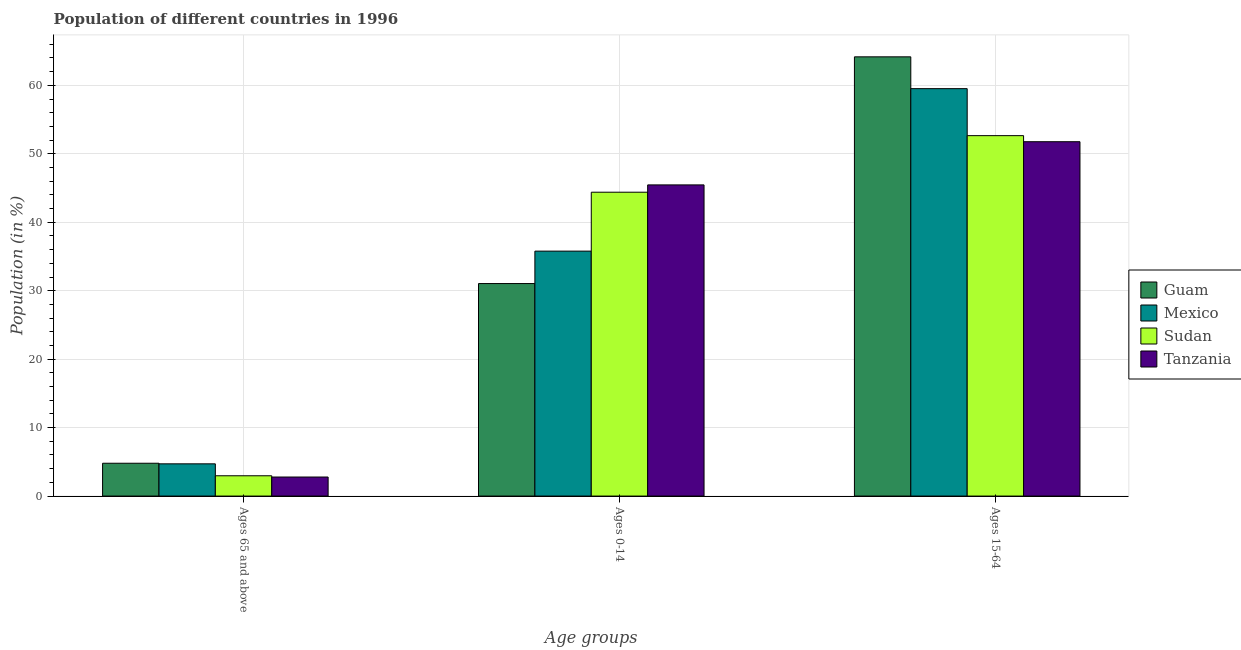How many different coloured bars are there?
Your response must be concise. 4. How many bars are there on the 2nd tick from the right?
Offer a terse response. 4. What is the label of the 2nd group of bars from the left?
Your response must be concise. Ages 0-14. What is the percentage of population within the age-group of 65 and above in Mexico?
Give a very brief answer. 4.71. Across all countries, what is the maximum percentage of population within the age-group 15-64?
Provide a short and direct response. 64.16. Across all countries, what is the minimum percentage of population within the age-group 0-14?
Give a very brief answer. 31.04. In which country was the percentage of population within the age-group of 65 and above maximum?
Your response must be concise. Guam. In which country was the percentage of population within the age-group 15-64 minimum?
Offer a terse response. Tanzania. What is the total percentage of population within the age-group of 65 and above in the graph?
Offer a terse response. 15.25. What is the difference between the percentage of population within the age-group 15-64 in Tanzania and that in Guam?
Give a very brief answer. -12.4. What is the difference between the percentage of population within the age-group 15-64 in Mexico and the percentage of population within the age-group of 65 and above in Guam?
Give a very brief answer. 54.72. What is the average percentage of population within the age-group of 65 and above per country?
Ensure brevity in your answer.  3.81. What is the difference between the percentage of population within the age-group 0-14 and percentage of population within the age-group of 65 and above in Guam?
Keep it short and to the point. 26.25. In how many countries, is the percentage of population within the age-group of 65 and above greater than 26 %?
Offer a terse response. 0. What is the ratio of the percentage of population within the age-group 0-14 in Mexico to that in Sudan?
Ensure brevity in your answer.  0.81. Is the difference between the percentage of population within the age-group 0-14 in Tanzania and Mexico greater than the difference between the percentage of population within the age-group of 65 and above in Tanzania and Mexico?
Your response must be concise. Yes. What is the difference between the highest and the second highest percentage of population within the age-group of 65 and above?
Make the answer very short. 0.09. What is the difference between the highest and the lowest percentage of population within the age-group 0-14?
Give a very brief answer. 14.41. In how many countries, is the percentage of population within the age-group 0-14 greater than the average percentage of population within the age-group 0-14 taken over all countries?
Provide a succinct answer. 2. Is the sum of the percentage of population within the age-group of 65 and above in Guam and Mexico greater than the maximum percentage of population within the age-group 15-64 across all countries?
Ensure brevity in your answer.  No. What does the 1st bar from the left in Ages 15-64 represents?
Your answer should be compact. Guam. What does the 1st bar from the right in Ages 65 and above represents?
Offer a terse response. Tanzania. Is it the case that in every country, the sum of the percentage of population within the age-group of 65 and above and percentage of population within the age-group 0-14 is greater than the percentage of population within the age-group 15-64?
Your response must be concise. No. Are all the bars in the graph horizontal?
Make the answer very short. No. Are the values on the major ticks of Y-axis written in scientific E-notation?
Offer a terse response. No. Does the graph contain any zero values?
Provide a succinct answer. No. What is the title of the graph?
Provide a short and direct response. Population of different countries in 1996. Does "Luxembourg" appear as one of the legend labels in the graph?
Make the answer very short. No. What is the label or title of the X-axis?
Ensure brevity in your answer.  Age groups. What is the label or title of the Y-axis?
Offer a terse response. Population (in %). What is the Population (in %) in Guam in Ages 65 and above?
Ensure brevity in your answer.  4.8. What is the Population (in %) of Mexico in Ages 65 and above?
Offer a terse response. 4.71. What is the Population (in %) of Sudan in Ages 65 and above?
Your answer should be very brief. 2.96. What is the Population (in %) in Tanzania in Ages 65 and above?
Provide a succinct answer. 2.78. What is the Population (in %) of Guam in Ages 0-14?
Ensure brevity in your answer.  31.04. What is the Population (in %) of Mexico in Ages 0-14?
Provide a short and direct response. 35.78. What is the Population (in %) in Sudan in Ages 0-14?
Provide a short and direct response. 44.39. What is the Population (in %) of Tanzania in Ages 0-14?
Provide a short and direct response. 45.45. What is the Population (in %) of Guam in Ages 15-64?
Give a very brief answer. 64.16. What is the Population (in %) in Mexico in Ages 15-64?
Your answer should be very brief. 59.51. What is the Population (in %) in Sudan in Ages 15-64?
Ensure brevity in your answer.  52.65. What is the Population (in %) in Tanzania in Ages 15-64?
Offer a terse response. 51.76. Across all Age groups, what is the maximum Population (in %) in Guam?
Offer a terse response. 64.16. Across all Age groups, what is the maximum Population (in %) in Mexico?
Offer a terse response. 59.51. Across all Age groups, what is the maximum Population (in %) of Sudan?
Make the answer very short. 52.65. Across all Age groups, what is the maximum Population (in %) of Tanzania?
Make the answer very short. 51.76. Across all Age groups, what is the minimum Population (in %) in Guam?
Your answer should be compact. 4.8. Across all Age groups, what is the minimum Population (in %) of Mexico?
Your answer should be compact. 4.71. Across all Age groups, what is the minimum Population (in %) in Sudan?
Provide a succinct answer. 2.96. Across all Age groups, what is the minimum Population (in %) in Tanzania?
Ensure brevity in your answer.  2.78. What is the total Population (in %) of Guam in the graph?
Offer a very short reply. 100. What is the total Population (in %) of Sudan in the graph?
Keep it short and to the point. 100. What is the difference between the Population (in %) of Guam in Ages 65 and above and that in Ages 0-14?
Offer a very short reply. -26.25. What is the difference between the Population (in %) of Mexico in Ages 65 and above and that in Ages 0-14?
Offer a very short reply. -31.07. What is the difference between the Population (in %) of Sudan in Ages 65 and above and that in Ages 0-14?
Keep it short and to the point. -41.42. What is the difference between the Population (in %) in Tanzania in Ages 65 and above and that in Ages 0-14?
Provide a succinct answer. -42.67. What is the difference between the Population (in %) of Guam in Ages 65 and above and that in Ages 15-64?
Provide a short and direct response. -59.37. What is the difference between the Population (in %) of Mexico in Ages 65 and above and that in Ages 15-64?
Give a very brief answer. -54.81. What is the difference between the Population (in %) in Sudan in Ages 65 and above and that in Ages 15-64?
Provide a succinct answer. -49.68. What is the difference between the Population (in %) of Tanzania in Ages 65 and above and that in Ages 15-64?
Offer a terse response. -48.98. What is the difference between the Population (in %) in Guam in Ages 0-14 and that in Ages 15-64?
Your response must be concise. -33.12. What is the difference between the Population (in %) of Mexico in Ages 0-14 and that in Ages 15-64?
Your answer should be compact. -23.74. What is the difference between the Population (in %) in Sudan in Ages 0-14 and that in Ages 15-64?
Your response must be concise. -8.26. What is the difference between the Population (in %) of Tanzania in Ages 0-14 and that in Ages 15-64?
Provide a short and direct response. -6.31. What is the difference between the Population (in %) of Guam in Ages 65 and above and the Population (in %) of Mexico in Ages 0-14?
Ensure brevity in your answer.  -30.98. What is the difference between the Population (in %) in Guam in Ages 65 and above and the Population (in %) in Sudan in Ages 0-14?
Your response must be concise. -39.59. What is the difference between the Population (in %) of Guam in Ages 65 and above and the Population (in %) of Tanzania in Ages 0-14?
Make the answer very short. -40.66. What is the difference between the Population (in %) in Mexico in Ages 65 and above and the Population (in %) in Sudan in Ages 0-14?
Ensure brevity in your answer.  -39.68. What is the difference between the Population (in %) of Mexico in Ages 65 and above and the Population (in %) of Tanzania in Ages 0-14?
Provide a succinct answer. -40.75. What is the difference between the Population (in %) of Sudan in Ages 65 and above and the Population (in %) of Tanzania in Ages 0-14?
Provide a short and direct response. -42.49. What is the difference between the Population (in %) in Guam in Ages 65 and above and the Population (in %) in Mexico in Ages 15-64?
Give a very brief answer. -54.72. What is the difference between the Population (in %) in Guam in Ages 65 and above and the Population (in %) in Sudan in Ages 15-64?
Your response must be concise. -47.85. What is the difference between the Population (in %) in Guam in Ages 65 and above and the Population (in %) in Tanzania in Ages 15-64?
Provide a succinct answer. -46.97. What is the difference between the Population (in %) of Mexico in Ages 65 and above and the Population (in %) of Sudan in Ages 15-64?
Your answer should be compact. -47.94. What is the difference between the Population (in %) in Mexico in Ages 65 and above and the Population (in %) in Tanzania in Ages 15-64?
Give a very brief answer. -47.06. What is the difference between the Population (in %) of Sudan in Ages 65 and above and the Population (in %) of Tanzania in Ages 15-64?
Ensure brevity in your answer.  -48.8. What is the difference between the Population (in %) of Guam in Ages 0-14 and the Population (in %) of Mexico in Ages 15-64?
Ensure brevity in your answer.  -28.47. What is the difference between the Population (in %) in Guam in Ages 0-14 and the Population (in %) in Sudan in Ages 15-64?
Your answer should be very brief. -21.61. What is the difference between the Population (in %) of Guam in Ages 0-14 and the Population (in %) of Tanzania in Ages 15-64?
Provide a succinct answer. -20.72. What is the difference between the Population (in %) of Mexico in Ages 0-14 and the Population (in %) of Sudan in Ages 15-64?
Ensure brevity in your answer.  -16.87. What is the difference between the Population (in %) of Mexico in Ages 0-14 and the Population (in %) of Tanzania in Ages 15-64?
Give a very brief answer. -15.99. What is the difference between the Population (in %) in Sudan in Ages 0-14 and the Population (in %) in Tanzania in Ages 15-64?
Offer a terse response. -7.38. What is the average Population (in %) in Guam per Age groups?
Ensure brevity in your answer.  33.33. What is the average Population (in %) in Mexico per Age groups?
Make the answer very short. 33.33. What is the average Population (in %) in Sudan per Age groups?
Your answer should be compact. 33.33. What is the average Population (in %) of Tanzania per Age groups?
Your answer should be compact. 33.33. What is the difference between the Population (in %) of Guam and Population (in %) of Mexico in Ages 65 and above?
Ensure brevity in your answer.  0.09. What is the difference between the Population (in %) of Guam and Population (in %) of Sudan in Ages 65 and above?
Ensure brevity in your answer.  1.83. What is the difference between the Population (in %) in Guam and Population (in %) in Tanzania in Ages 65 and above?
Provide a succinct answer. 2.01. What is the difference between the Population (in %) of Mexico and Population (in %) of Sudan in Ages 65 and above?
Your response must be concise. 1.74. What is the difference between the Population (in %) in Mexico and Population (in %) in Tanzania in Ages 65 and above?
Ensure brevity in your answer.  1.93. What is the difference between the Population (in %) of Sudan and Population (in %) of Tanzania in Ages 65 and above?
Make the answer very short. 0.18. What is the difference between the Population (in %) in Guam and Population (in %) in Mexico in Ages 0-14?
Your answer should be compact. -4.74. What is the difference between the Population (in %) of Guam and Population (in %) of Sudan in Ages 0-14?
Make the answer very short. -13.34. What is the difference between the Population (in %) in Guam and Population (in %) in Tanzania in Ages 0-14?
Ensure brevity in your answer.  -14.41. What is the difference between the Population (in %) in Mexico and Population (in %) in Sudan in Ages 0-14?
Keep it short and to the point. -8.61. What is the difference between the Population (in %) in Mexico and Population (in %) in Tanzania in Ages 0-14?
Keep it short and to the point. -9.68. What is the difference between the Population (in %) in Sudan and Population (in %) in Tanzania in Ages 0-14?
Make the answer very short. -1.07. What is the difference between the Population (in %) of Guam and Population (in %) of Mexico in Ages 15-64?
Make the answer very short. 4.65. What is the difference between the Population (in %) in Guam and Population (in %) in Sudan in Ages 15-64?
Your answer should be compact. 11.51. What is the difference between the Population (in %) of Guam and Population (in %) of Tanzania in Ages 15-64?
Make the answer very short. 12.4. What is the difference between the Population (in %) of Mexico and Population (in %) of Sudan in Ages 15-64?
Your answer should be very brief. 6.86. What is the difference between the Population (in %) of Mexico and Population (in %) of Tanzania in Ages 15-64?
Ensure brevity in your answer.  7.75. What is the difference between the Population (in %) of Sudan and Population (in %) of Tanzania in Ages 15-64?
Keep it short and to the point. 0.89. What is the ratio of the Population (in %) of Guam in Ages 65 and above to that in Ages 0-14?
Offer a very short reply. 0.15. What is the ratio of the Population (in %) in Mexico in Ages 65 and above to that in Ages 0-14?
Ensure brevity in your answer.  0.13. What is the ratio of the Population (in %) of Sudan in Ages 65 and above to that in Ages 0-14?
Offer a very short reply. 0.07. What is the ratio of the Population (in %) in Tanzania in Ages 65 and above to that in Ages 0-14?
Give a very brief answer. 0.06. What is the ratio of the Population (in %) of Guam in Ages 65 and above to that in Ages 15-64?
Provide a succinct answer. 0.07. What is the ratio of the Population (in %) of Mexico in Ages 65 and above to that in Ages 15-64?
Make the answer very short. 0.08. What is the ratio of the Population (in %) in Sudan in Ages 65 and above to that in Ages 15-64?
Provide a short and direct response. 0.06. What is the ratio of the Population (in %) in Tanzania in Ages 65 and above to that in Ages 15-64?
Offer a very short reply. 0.05. What is the ratio of the Population (in %) of Guam in Ages 0-14 to that in Ages 15-64?
Offer a terse response. 0.48. What is the ratio of the Population (in %) of Mexico in Ages 0-14 to that in Ages 15-64?
Provide a short and direct response. 0.6. What is the ratio of the Population (in %) of Sudan in Ages 0-14 to that in Ages 15-64?
Your answer should be very brief. 0.84. What is the ratio of the Population (in %) of Tanzania in Ages 0-14 to that in Ages 15-64?
Give a very brief answer. 0.88. What is the difference between the highest and the second highest Population (in %) of Guam?
Ensure brevity in your answer.  33.12. What is the difference between the highest and the second highest Population (in %) of Mexico?
Ensure brevity in your answer.  23.74. What is the difference between the highest and the second highest Population (in %) of Sudan?
Offer a terse response. 8.26. What is the difference between the highest and the second highest Population (in %) of Tanzania?
Your response must be concise. 6.31. What is the difference between the highest and the lowest Population (in %) of Guam?
Give a very brief answer. 59.37. What is the difference between the highest and the lowest Population (in %) in Mexico?
Your response must be concise. 54.81. What is the difference between the highest and the lowest Population (in %) of Sudan?
Offer a very short reply. 49.68. What is the difference between the highest and the lowest Population (in %) of Tanzania?
Your response must be concise. 48.98. 